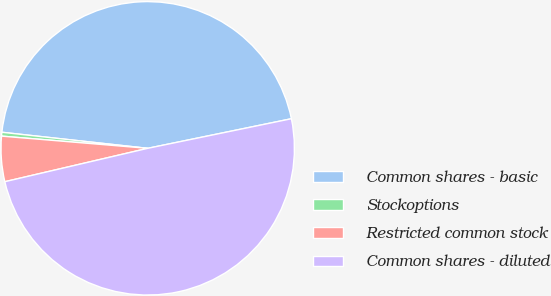Convert chart. <chart><loc_0><loc_0><loc_500><loc_500><pie_chart><fcel>Common shares - basic<fcel>Stockoptions<fcel>Restricted common stock<fcel>Common shares - diluted<nl><fcel>45.02%<fcel>0.42%<fcel>4.98%<fcel>49.58%<nl></chart> 